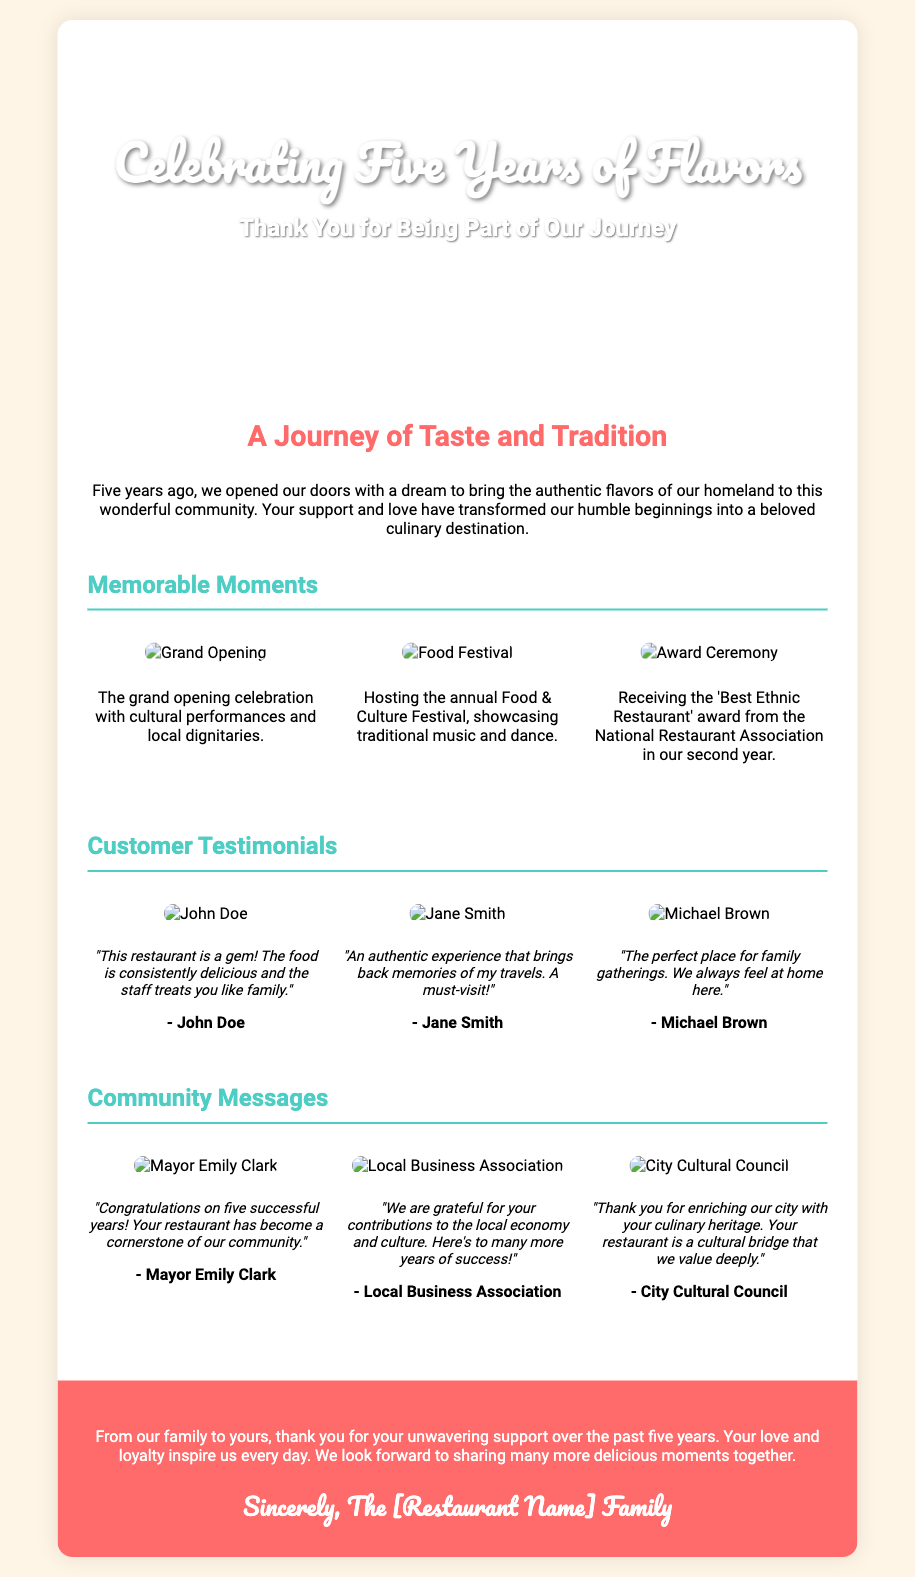What is the name of the restaurant chain? The greeting card does not explicitly mention the name of the restaurant; it refers to it as "[Restaurant Name]" in the signature.
Answer: [Restaurant Name] How many years is the restaurant chain celebrating? The document states that it is celebrating its 5th anniversary.
Answer: 5 What is the title of the card? The title given on the front cover of the card is "Celebrating Five Years of Flavors."
Answer: Celebrating Five Years of Flavors Who is the first customer testimonial from? The first testimonial is attributed to John Doe.
Answer: John Doe What award did the restaurant receive in its second year? The document mentions that the restaurant received the 'Best Ethnic Restaurant' award.
Answer: Best Ethnic Restaurant What color is the back cover of the card? The back cover of the card is colored in a shade of red, specifically #FF6B6B.
Answer: Red Who congratulated the restaurant on its fifth successful year? Mayor Emily Clark congratulated the restaurant on its fifth successful year.
Answer: Mayor Emily Clark What event was hosted to showcase traditional music and dance? The document specifies that an annual Food & Culture Festival was hosted for this purpose.
Answer: Food & Culture Festival What kind of performances were held during the grand opening? The grand opening celebration included cultural performances.
Answer: Cultural performances 